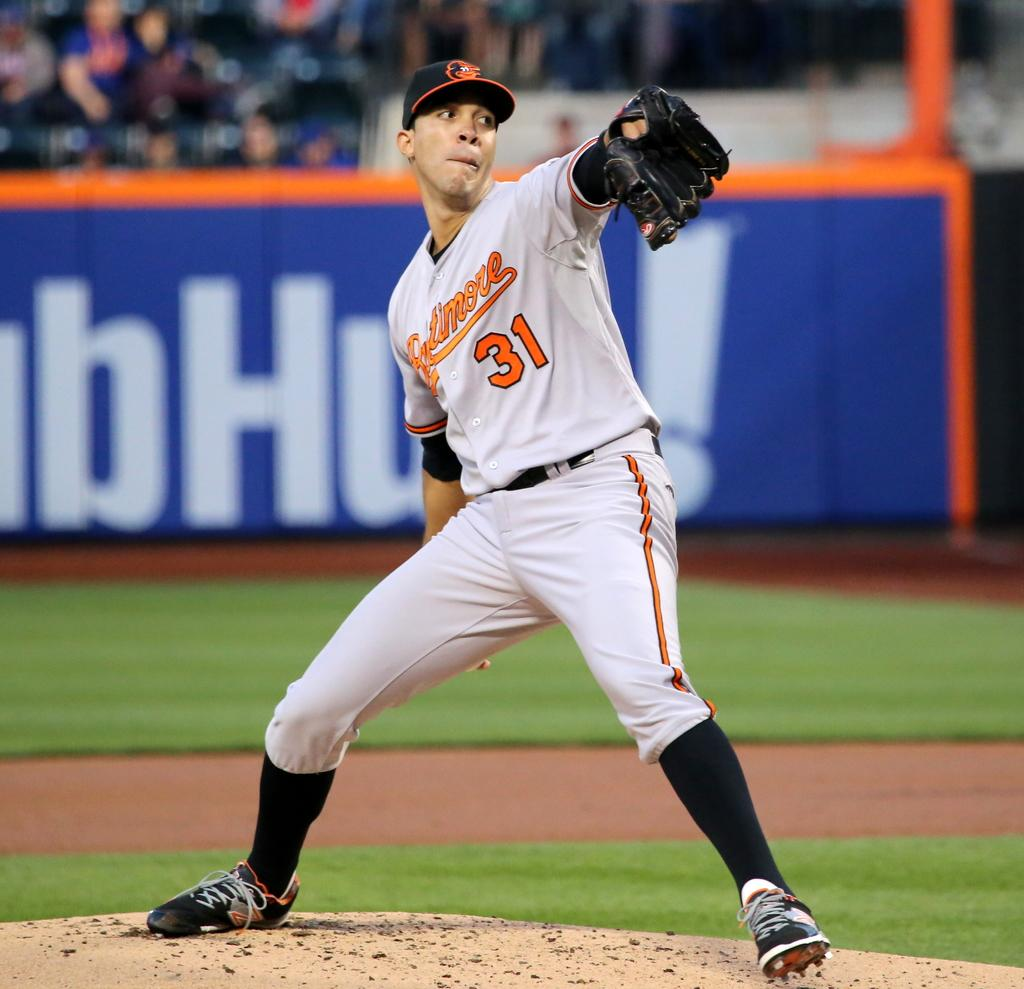<image>
Summarize the visual content of the image. Player number 31 for Baltimore has his hand back as he prepares to throw the ball. 